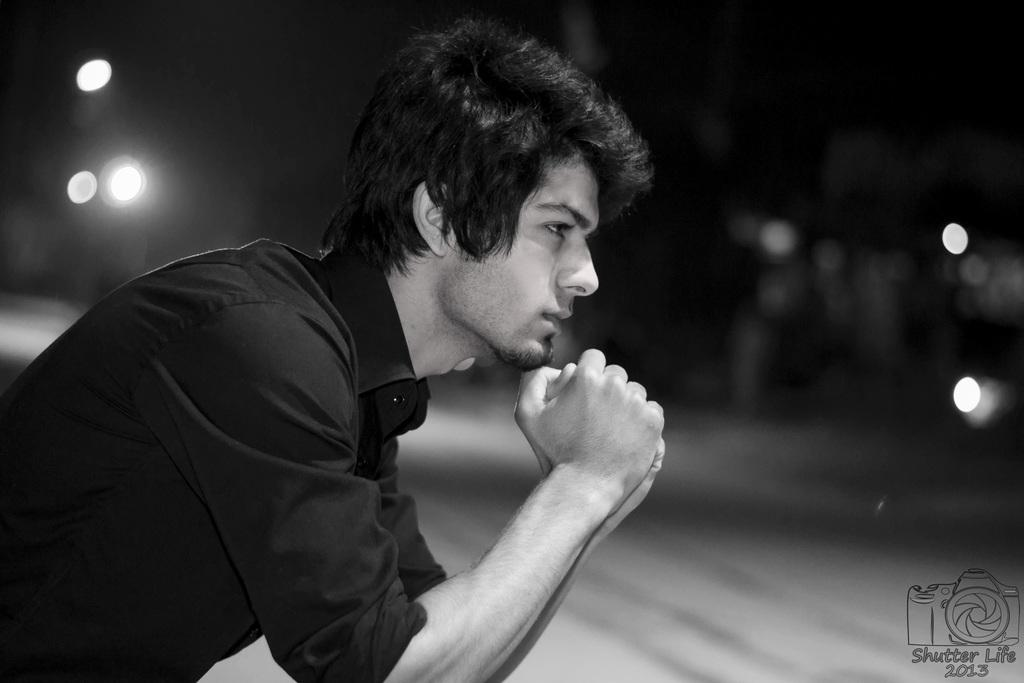Who is present in the image? There is a man in the image. What is the man wearing? The man is wearing a shirt. Can you describe any additional features of the image? There is a watermark in the bottom right corner of the image, and the background is blurred. What is the color scheme of the image? The image is black and white. What type of thought can be seen on the man's chin in the image? There is no thought visible on the man's chin in the image, as thoughts are not visible in this way. Can you tell me how many teeth the man has in the image? It is not possible to determine the number of teeth the man has in the image, as the image is black and white and does not provide a clear view of his teeth. 